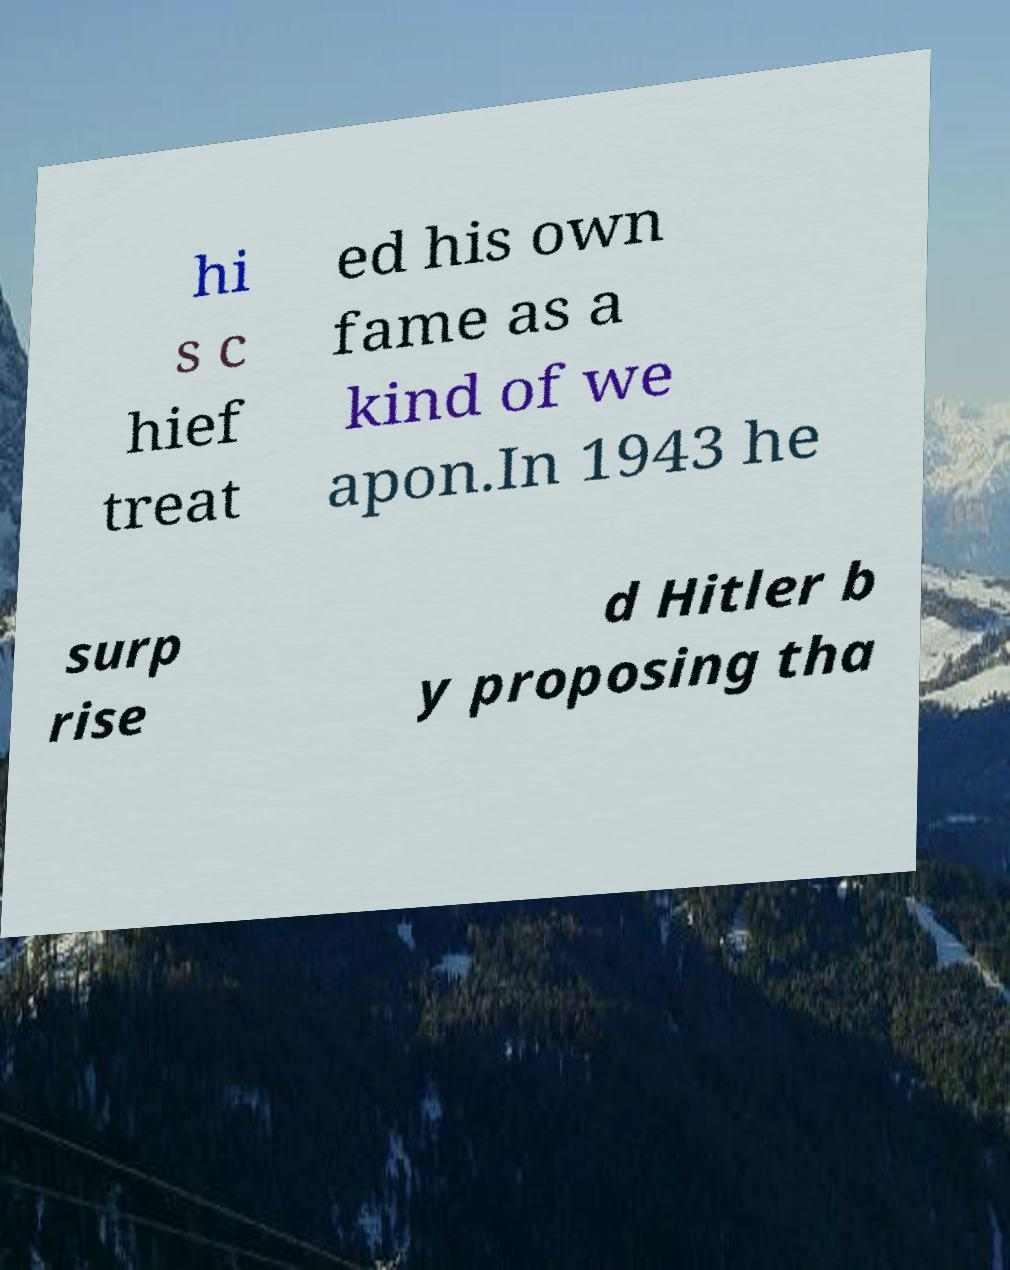Please identify and transcribe the text found in this image. hi s c hief treat ed his own fame as a kind of we apon.In 1943 he surp rise d Hitler b y proposing tha 